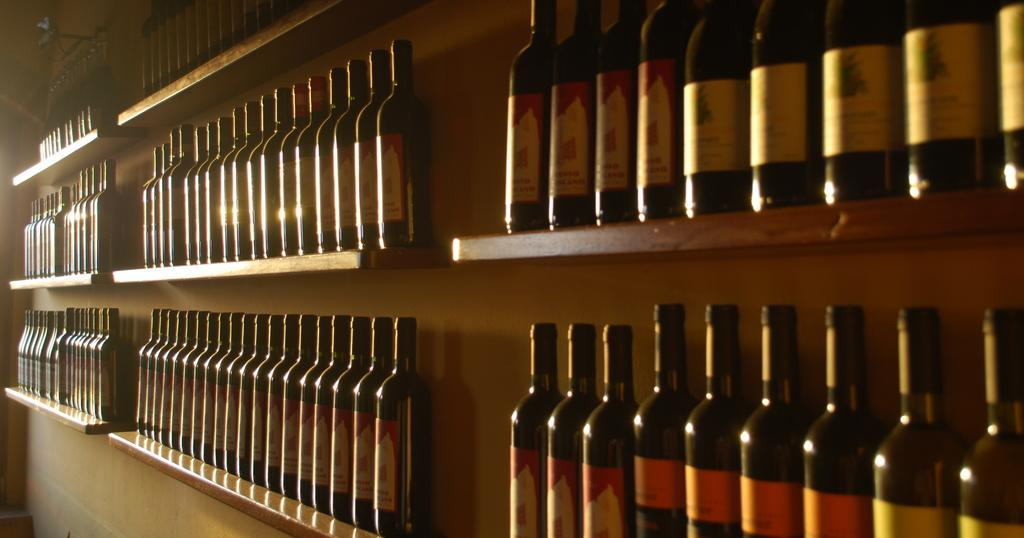What objects are present in the image in a group? There is a group of bottles in the image. What feature do all the bottles have in common? Each bottle has a lid and a label. How are the bottles arranged in the image? The bottles are arranged in an order. What material is the rack made of that holds the bottles? The bottles are placed in a wooden rack. What type of fuel is being stored in the bottles in the image? There is no indication in the image that the bottles contain any type of fuel. 